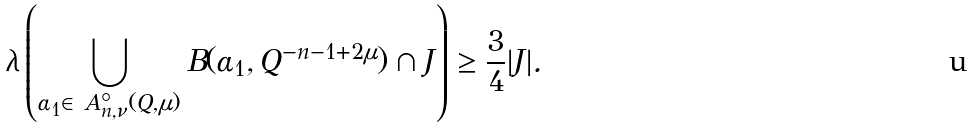Convert formula to latex. <formula><loc_0><loc_0><loc_500><loc_500>\lambda \left ( \bigcup _ { \alpha _ { 1 } \in \ A ^ { \circ } _ { n , \nu } ( Q , \mu ) } B ( \alpha _ { 1 } , Q ^ { - n - 1 + 2 \mu } ) \cap J \right ) \geq \frac { 3 } { 4 } | J | .</formula> 